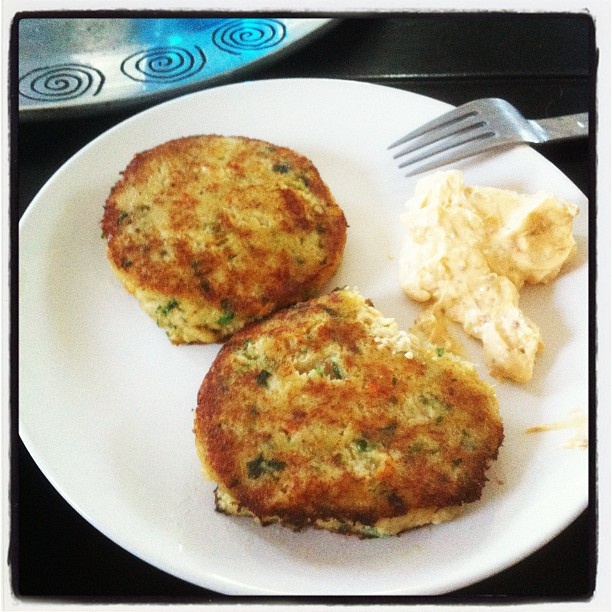Describe the objects in this image and their specific colors. I can see dining table in ivory, white, black, brown, and tan tones, donut in white, brown, tan, maroon, and orange tones, and fork in white, darkgray, lightgray, gray, and black tones in this image. 